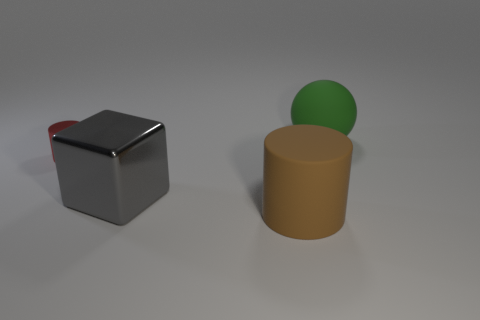Are there fewer tiny shiny cylinders than metal objects?
Offer a very short reply. Yes. The big thing that is to the left of the large rubber object in front of the matte object that is behind the small cylinder is what shape?
Give a very brief answer. Cube. Is there a large red metallic cube?
Offer a terse response. No. There is a cube; is it the same size as the rubber object to the left of the rubber ball?
Your answer should be compact. Yes. Is there a gray metallic block that is to the right of the shiny object behind the big gray thing?
Provide a succinct answer. Yes. There is a thing that is to the left of the large brown cylinder and to the right of the metallic cylinder; what material is it?
Make the answer very short. Metal. What color is the cylinder that is behind the big matte thing in front of the big object that is behind the red thing?
Your answer should be very brief. Red. There is a matte cylinder that is the same size as the green rubber ball; what color is it?
Ensure brevity in your answer.  Brown. Do the tiny metal cylinder and the cylinder that is on the right side of the gray metal cube have the same color?
Keep it short and to the point. No. The large object right of the large rubber thing that is in front of the green matte object is made of what material?
Make the answer very short. Rubber. 